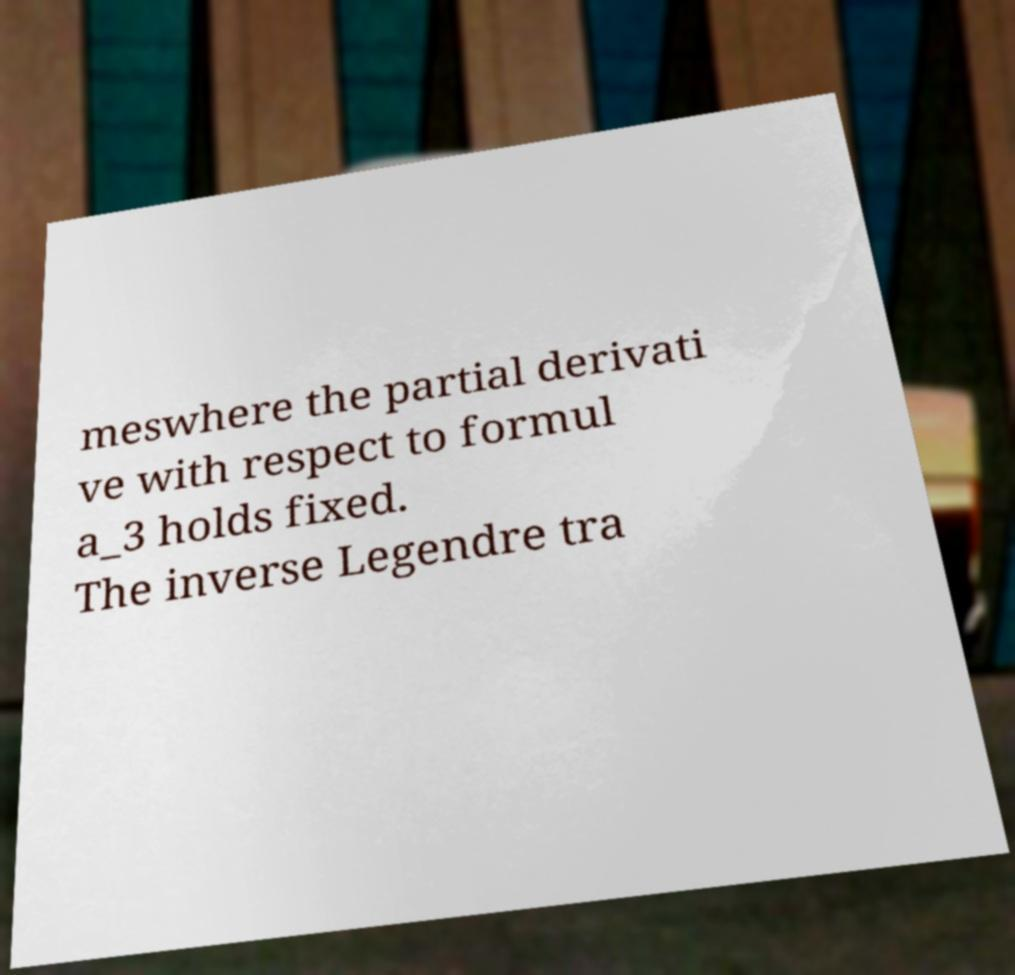Could you assist in decoding the text presented in this image and type it out clearly? meswhere the partial derivati ve with respect to formul a_3 holds fixed. The inverse Legendre tra 